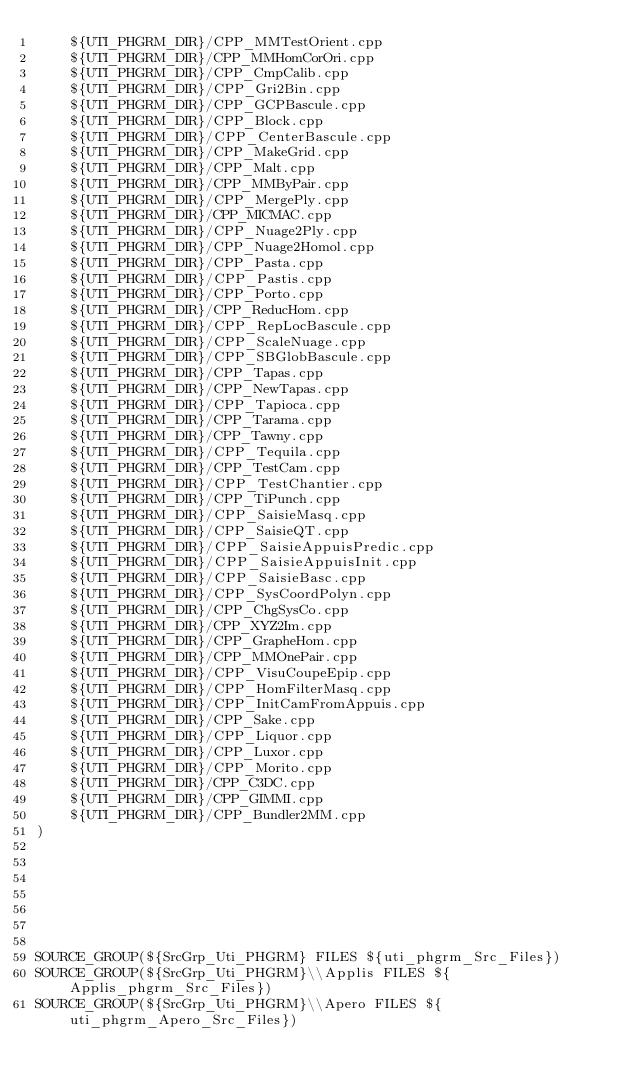<code> <loc_0><loc_0><loc_500><loc_500><_CMake_>    ${UTI_PHGRM_DIR}/CPP_MMTestOrient.cpp
    ${UTI_PHGRM_DIR}/CPP_MMHomCorOri.cpp
    ${UTI_PHGRM_DIR}/CPP_CmpCalib.cpp
    ${UTI_PHGRM_DIR}/CPP_Gri2Bin.cpp
    ${UTI_PHGRM_DIR}/CPP_GCPBascule.cpp
    ${UTI_PHGRM_DIR}/CPP_Block.cpp
    ${UTI_PHGRM_DIR}/CPP_CenterBascule.cpp
    ${UTI_PHGRM_DIR}/CPP_MakeGrid.cpp
    ${UTI_PHGRM_DIR}/CPP_Malt.cpp
    ${UTI_PHGRM_DIR}/CPP_MMByPair.cpp
    ${UTI_PHGRM_DIR}/CPP_MergePly.cpp
    ${UTI_PHGRM_DIR}/CPP_MICMAC.cpp
    ${UTI_PHGRM_DIR}/CPP_Nuage2Ply.cpp
    ${UTI_PHGRM_DIR}/CPP_Nuage2Homol.cpp
    ${UTI_PHGRM_DIR}/CPP_Pasta.cpp
    ${UTI_PHGRM_DIR}/CPP_Pastis.cpp
    ${UTI_PHGRM_DIR}/CPP_Porto.cpp
    ${UTI_PHGRM_DIR}/CPP_ReducHom.cpp
    ${UTI_PHGRM_DIR}/CPP_RepLocBascule.cpp
    ${UTI_PHGRM_DIR}/CPP_ScaleNuage.cpp
    ${UTI_PHGRM_DIR}/CPP_SBGlobBascule.cpp
    ${UTI_PHGRM_DIR}/CPP_Tapas.cpp
    ${UTI_PHGRM_DIR}/CPP_NewTapas.cpp
    ${UTI_PHGRM_DIR}/CPP_Tapioca.cpp
    ${UTI_PHGRM_DIR}/CPP_Tarama.cpp
    ${UTI_PHGRM_DIR}/CPP_Tawny.cpp
    ${UTI_PHGRM_DIR}/CPP_Tequila.cpp
    ${UTI_PHGRM_DIR}/CPP_TestCam.cpp
    ${UTI_PHGRM_DIR}/CPP_TestChantier.cpp
    ${UTI_PHGRM_DIR}/CPP_TiPunch.cpp
    ${UTI_PHGRM_DIR}/CPP_SaisieMasq.cpp
    ${UTI_PHGRM_DIR}/CPP_SaisieQT.cpp
    ${UTI_PHGRM_DIR}/CPP_SaisieAppuisPredic.cpp
    ${UTI_PHGRM_DIR}/CPP_SaisieAppuisInit.cpp
    ${UTI_PHGRM_DIR}/CPP_SaisieBasc.cpp
    ${UTI_PHGRM_DIR}/CPP_SysCoordPolyn.cpp
    ${UTI_PHGRM_DIR}/CPP_ChgSysCo.cpp
    ${UTI_PHGRM_DIR}/CPP_XYZ2Im.cpp
    ${UTI_PHGRM_DIR}/CPP_GrapheHom.cpp
    ${UTI_PHGRM_DIR}/CPP_MMOnePair.cpp
    ${UTI_PHGRM_DIR}/CPP_VisuCoupeEpip.cpp
    ${UTI_PHGRM_DIR}/CPP_HomFilterMasq.cpp
    ${UTI_PHGRM_DIR}/CPP_InitCamFromAppuis.cpp
    ${UTI_PHGRM_DIR}/CPP_Sake.cpp
    ${UTI_PHGRM_DIR}/CPP_Liquor.cpp
    ${UTI_PHGRM_DIR}/CPP_Luxor.cpp 
    ${UTI_PHGRM_DIR}/CPP_Morito.cpp
    ${UTI_PHGRM_DIR}/CPP_C3DC.cpp
    ${UTI_PHGRM_DIR}/CPP_GIMMI.cpp
    ${UTI_PHGRM_DIR}/CPP_Bundler2MM.cpp
)



  
  


SOURCE_GROUP(${SrcGrp_Uti_PHGRM} FILES ${uti_phgrm_Src_Files})
SOURCE_GROUP(${SrcGrp_Uti_PHGRM}\\Applis FILES ${Applis_phgrm_Src_Files})
SOURCE_GROUP(${SrcGrp_Uti_PHGRM}\\Apero FILES ${uti_phgrm_Apero_Src_Files})</code> 